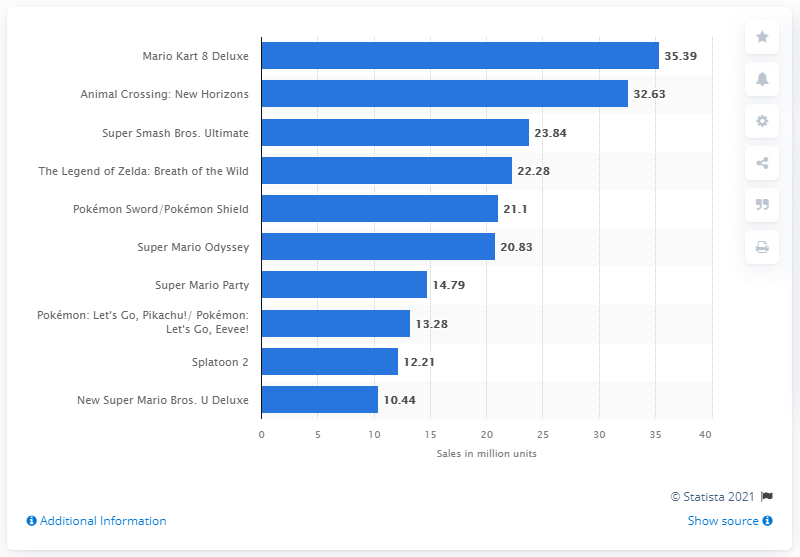Give some essential details in this illustration. As of March 2021, Mario Kart 8 Deluxe was the top-selling Nintendo Switch game. The only entry in the top list that was released in 2020 is Animal Crossing: New Horizons. 